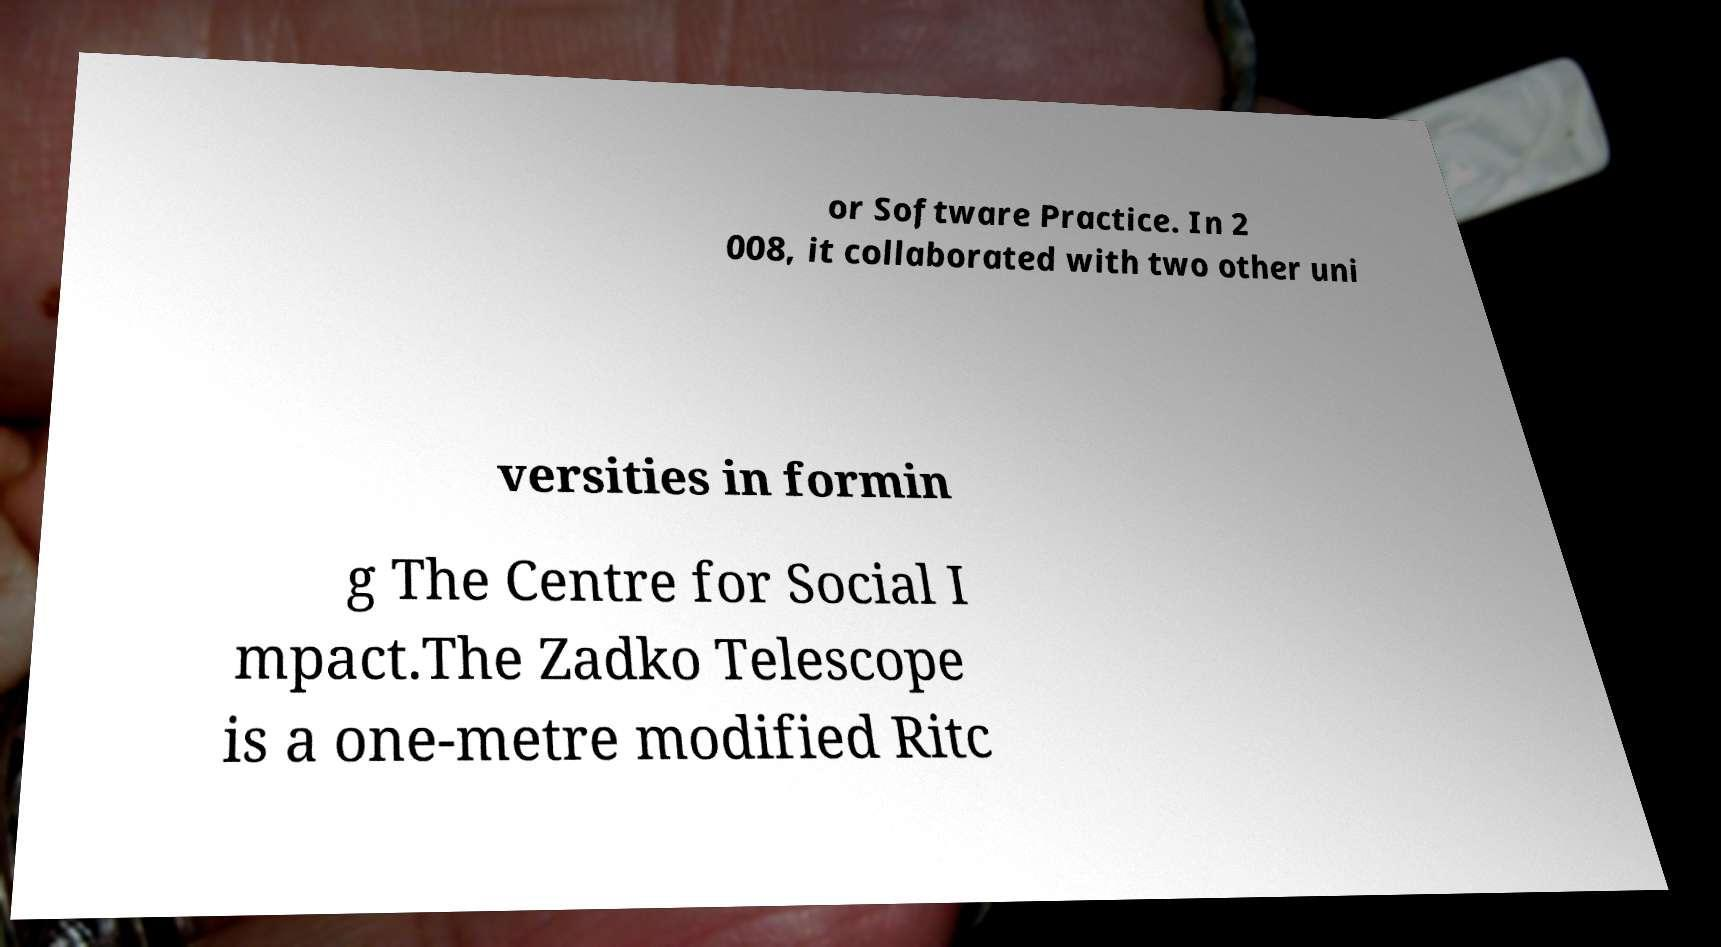Please identify and transcribe the text found in this image. or Software Practice. In 2 008, it collaborated with two other uni versities in formin g The Centre for Social I mpact.The Zadko Telescope is a one-metre modified Ritc 